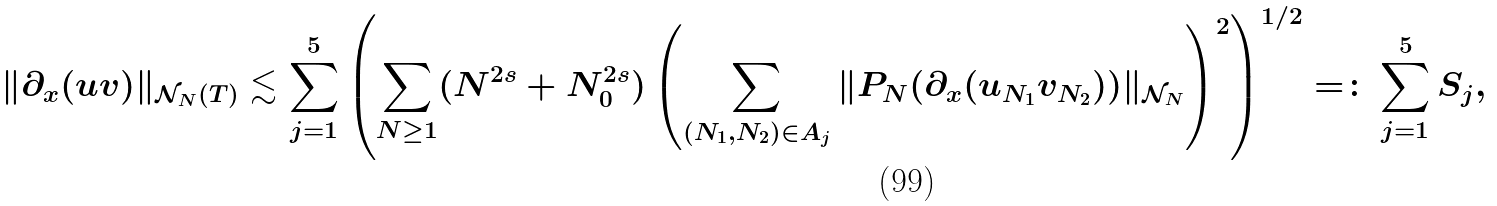<formula> <loc_0><loc_0><loc_500><loc_500>\| \partial _ { x } ( u v ) \| _ { \mathcal { N } _ { N } ( T ) } & \lesssim \sum _ { j = 1 } ^ { 5 } \left ( \sum _ { N \geq 1 } ( N ^ { 2 s } + N _ { 0 } ^ { 2 s } ) \left ( \sum _ { ( N _ { 1 } , N _ { 2 } ) \in A _ { j } } \| P _ { N } ( \partial _ { x } ( u _ { N _ { 1 } } v _ { N _ { 2 } } ) ) \| _ { \mathcal { N } _ { N } } \right ) ^ { 2 } \right ) ^ { 1 / 2 } = \colon \sum _ { j = 1 } ^ { 5 } S _ { j } ,</formula> 